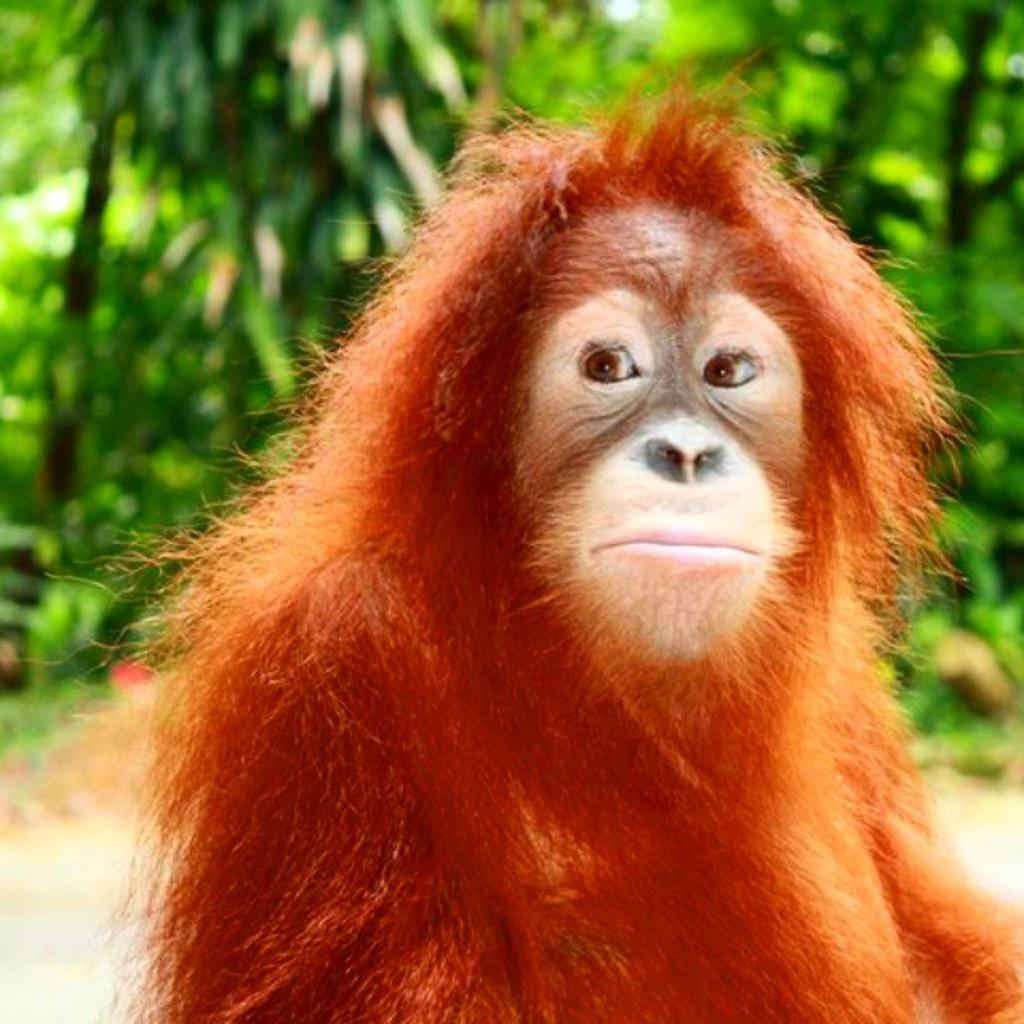What type of animal is in the image? There is an orangutan in the image. What can be seen in the background of the image? There are trees in the image. How would you describe the overall focus of the image? The background of the image is slightly blurred. What type of steel is being used to build the snowman in the image? There is no snowman or steel present in the image; it features an orangutan and trees. 